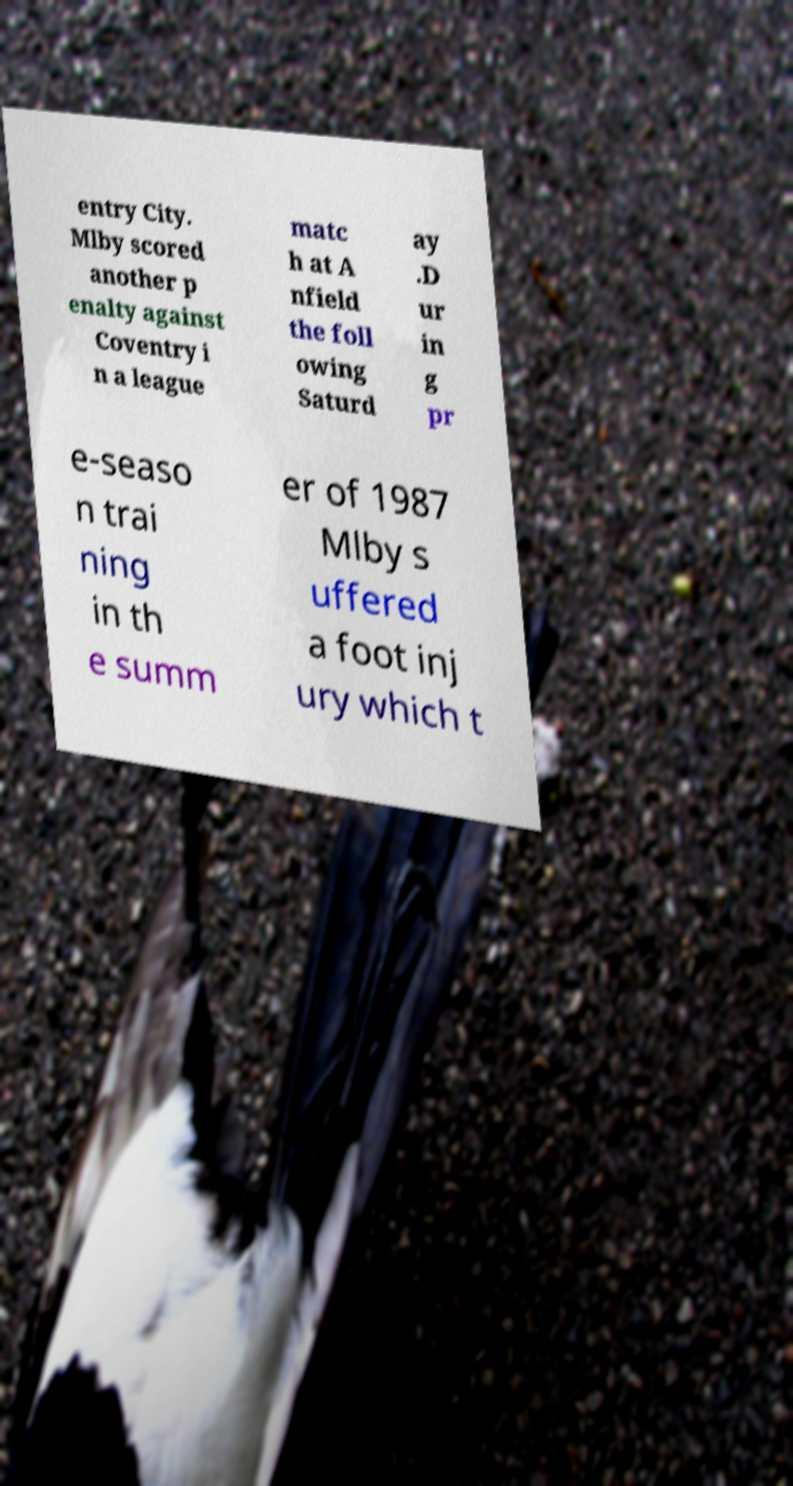For documentation purposes, I need the text within this image transcribed. Could you provide that? entry City. Mlby scored another p enalty against Coventry i n a league matc h at A nfield the foll owing Saturd ay .D ur in g pr e-seaso n trai ning in th e summ er of 1987 Mlby s uffered a foot inj ury which t 